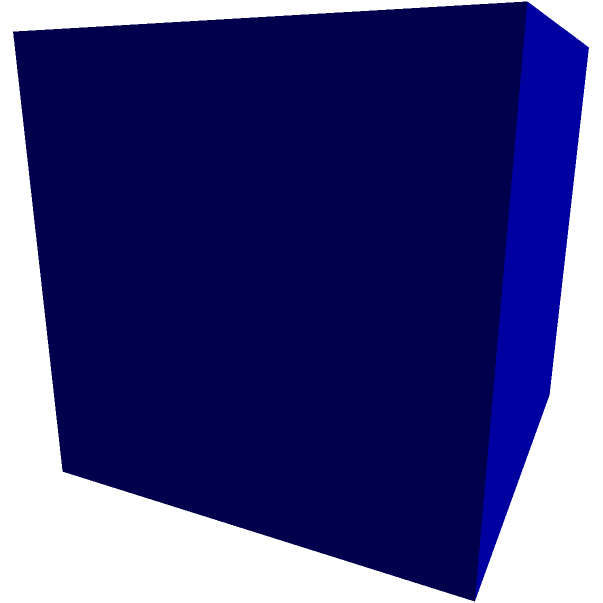In your therapy practice, you often use metaphors to help couples visualize their relationship dynamics. Consider a rectangular prism representing the emotional space of a divorcing couple. If the prism has dimensions of 4 cm, 3 cm, and 5 cm, what is the total surface area of this "emotional space" that needs to be addressed during the divorce process? Let's approach this step-by-step:

1) The surface area of a rectangular prism is the sum of the areas of all six faces.

2) The prism has three pairs of identical faces:
   - Two faces with dimensions 4 cm × 3 cm
   - Two faces with dimensions 4 cm × 5 cm
   - Two faces with dimensions 3 cm × 5 cm

3) Let's calculate the area of each pair:
   - Area of 4 cm × 3 cm faces: $A_1 = 4 \times 3 = 12$ cm²
   - Area of 4 cm × 5 cm faces: $A_2 = 4 \times 5 = 20$ cm²
   - Area of 3 cm × 5 cm faces: $A_3 = 3 \times 5 = 15$ cm²

4) Now, we need to multiply each area by 2 (because there are two of each) and sum them:
   Total Surface Area = $2(A_1 + A_2 + A_3)$
                      = $2(12 + 20 + 15)$
                      = $2(47)$
                      = $94$ cm²

Therefore, the total surface area of the "emotional space" prism is 94 square centimeters.
Answer: 94 cm² 